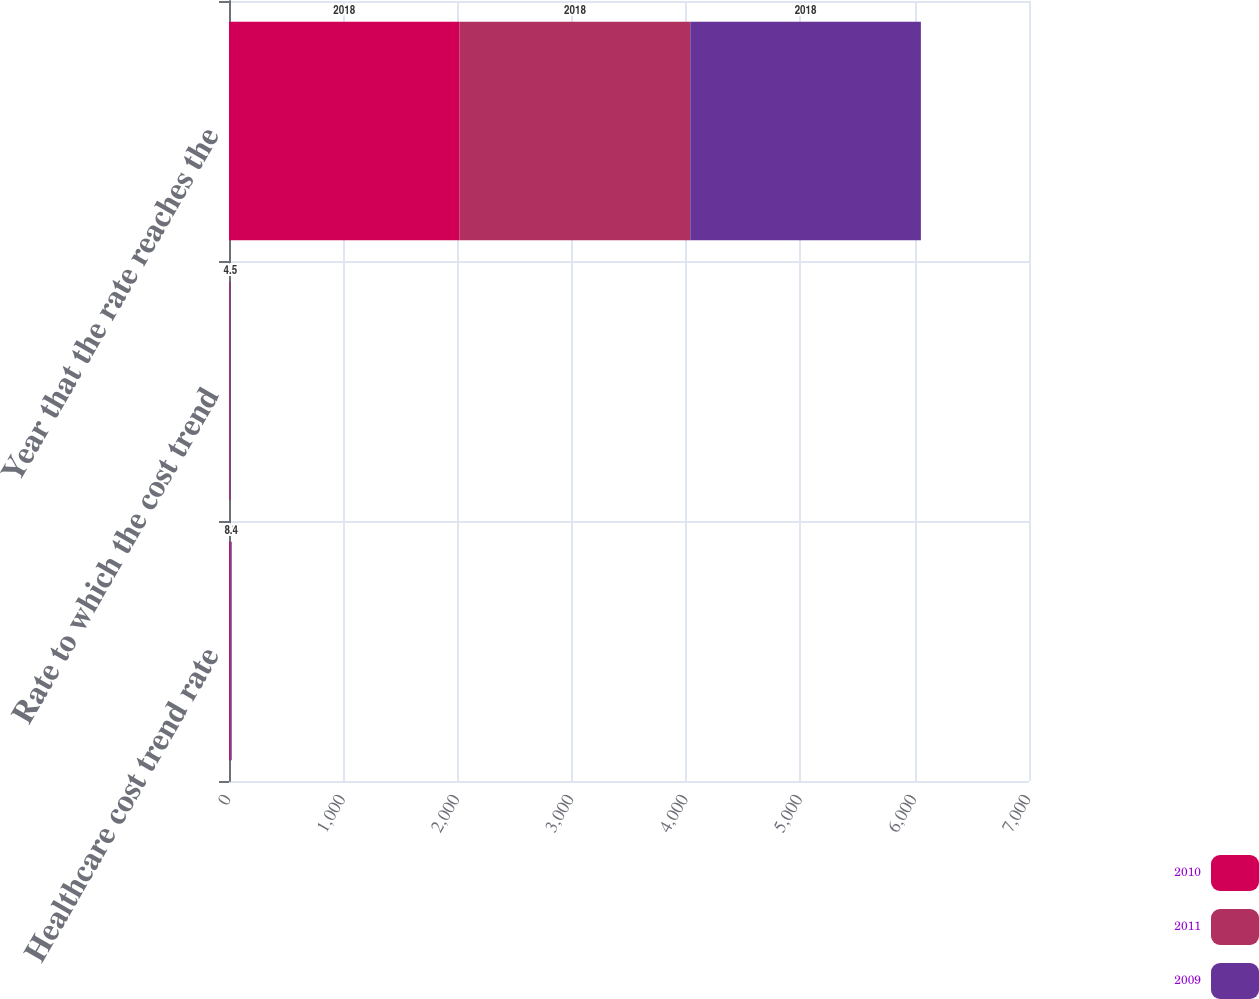Convert chart to OTSL. <chart><loc_0><loc_0><loc_500><loc_500><stacked_bar_chart><ecel><fcel>Healthcare cost trend rate<fcel>Rate to which the cost trend<fcel>Year that the rate reaches the<nl><fcel>2010<fcel>7.4<fcel>4.5<fcel>2018<nl><fcel>2011<fcel>7.9<fcel>4.5<fcel>2018<nl><fcel>2009<fcel>8.4<fcel>4.5<fcel>2018<nl></chart> 